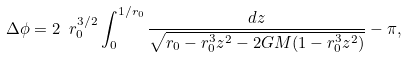Convert formula to latex. <formula><loc_0><loc_0><loc_500><loc_500>\Delta \phi = 2 \ r _ { 0 } ^ { 3 / 2 } \int _ { 0 } ^ { 1 / r _ { 0 } } \frac { d z } { \sqrt { r _ { 0 } - r _ { 0 } ^ { 3 } z ^ { 2 } - 2 G M ( 1 - r _ { 0 } ^ { 3 } z ^ { 2 } ) } } - \pi ,</formula> 